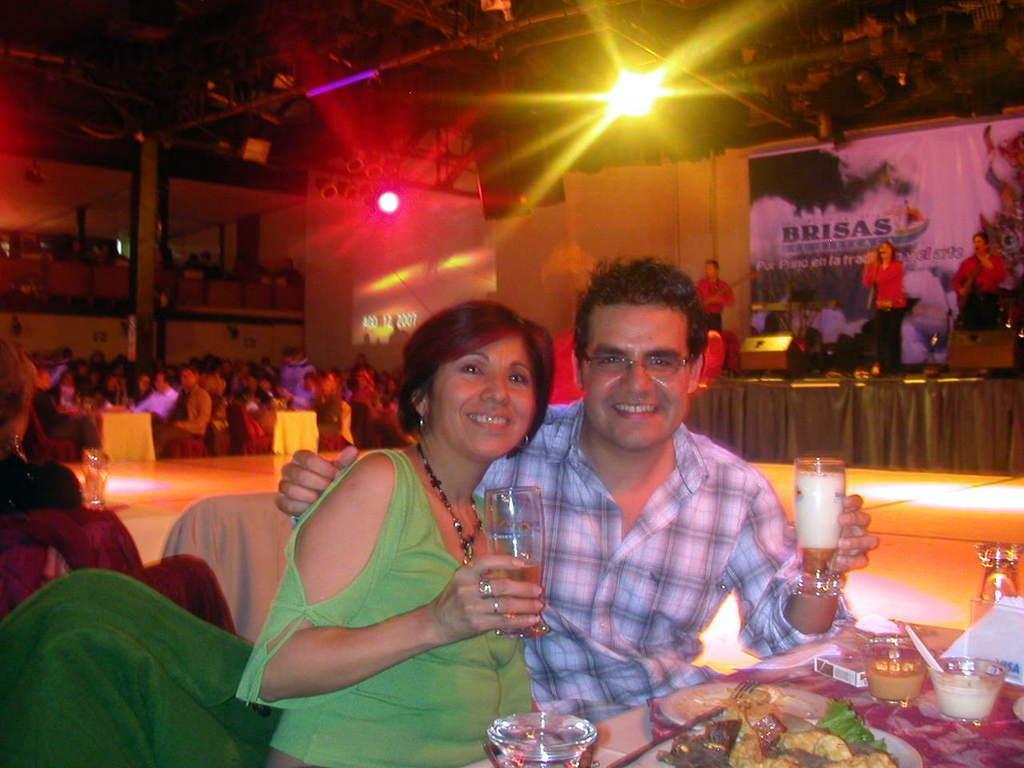Can you describe this image briefly? It looks like an event, few people were performing on the stage and the crowd is sitting around the tables, in the front two people were having some food both of them are posing for the photo by holding some drinks with their hands and in the background there are two different lights focusing on the entire hall. 